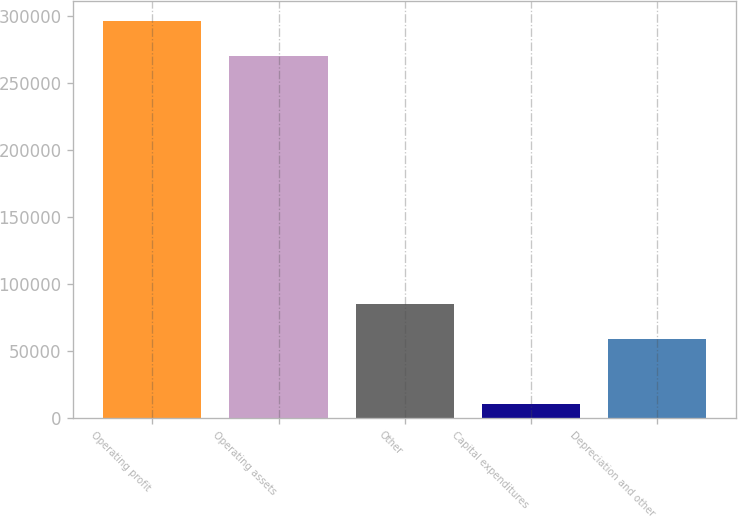Convert chart to OTSL. <chart><loc_0><loc_0><loc_500><loc_500><bar_chart><fcel>Operating profit<fcel>Operating assets<fcel>Other<fcel>Capital expenditures<fcel>Depreciation and other<nl><fcel>296524<fcel>270458<fcel>84767.6<fcel>10521<fcel>58702<nl></chart> 